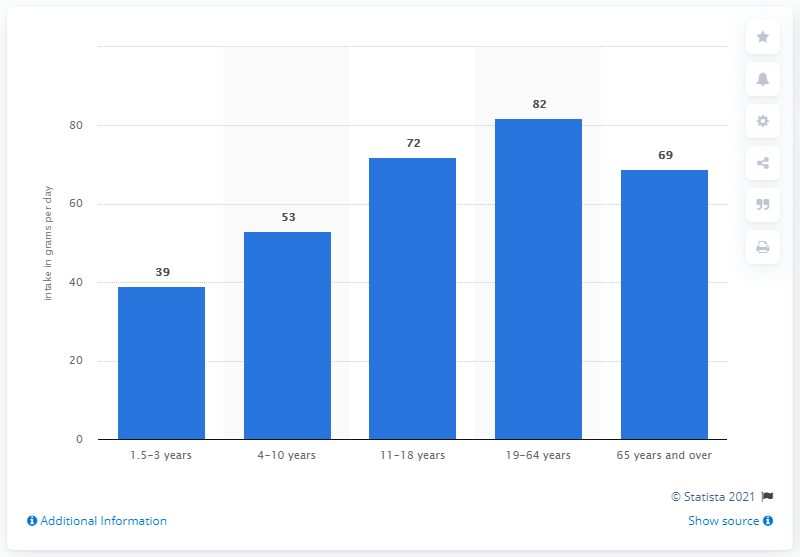Outline some significant characteristics in this image. The average intake for individuals aged 11 to 18 is approximately 72. The number of categories that are less than the 19-64 age category is four. 